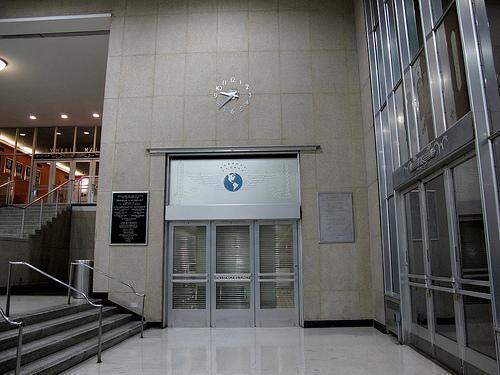How many doors are under the clock?
Give a very brief answer. 3. 